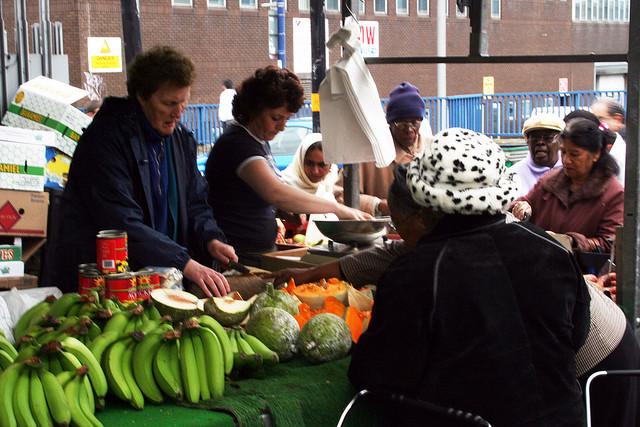What color is the railing?
Write a very short answer. Blue. Are the bananas ripe?
Keep it brief. No. Where is the weighing scale?
Write a very short answer. Middle. 